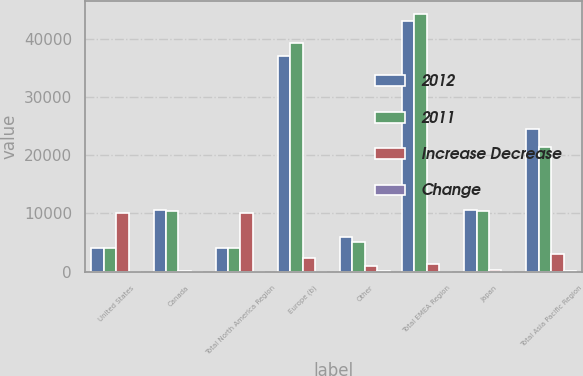Convert chart to OTSL. <chart><loc_0><loc_0><loc_500><loc_500><stacked_bar_chart><ecel><fcel>United States<fcel>Canada<fcel>Total North America Region<fcel>Europe (b)<fcel>Other<fcel>Total EMEA Region<fcel>Japan<fcel>Total Asia Pacific Region<nl><fcel>2012<fcel>4035.5<fcel>10573<fcel>4035.5<fcel>37027<fcel>6000<fcel>43027<fcel>10642<fcel>24481<nl><fcel>2011<fcel>4035.5<fcel>10502<fcel>4035.5<fcel>39334<fcel>5006<fcel>44340<fcel>10401<fcel>21416<nl><fcel>Increase Decrease<fcel>9995<fcel>71<fcel>10066<fcel>2307<fcel>994<fcel>1313<fcel>241<fcel>3065<nl><fcel>Change<fcel>6.6<fcel>0.7<fcel>6.2<fcel>5.9<fcel>19.9<fcel>3<fcel>2.3<fcel>14.3<nl></chart> 